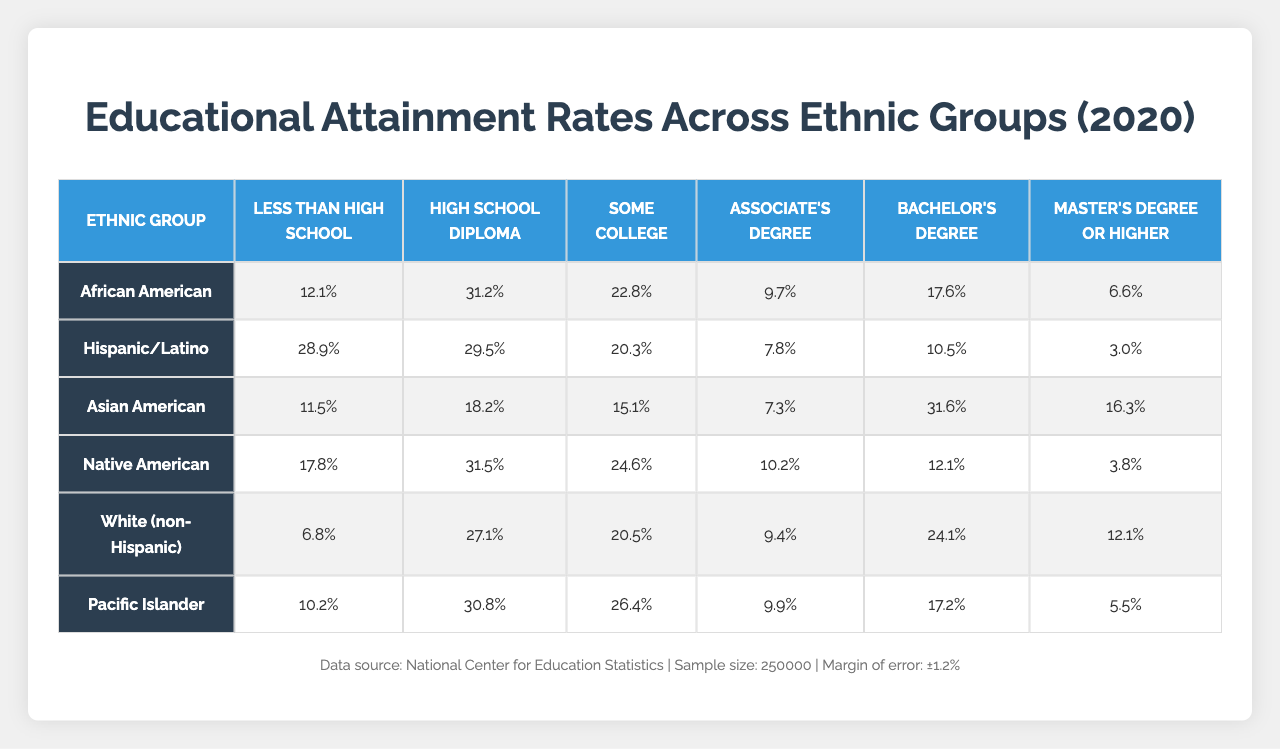What is the education attainment rate for Asian Americans for a Bachelor's Degree? The table lists the attainment rates for each ethnic group across various education levels. For Asian Americans, the rate for a Bachelor's Degree is shown in the corresponding cell.
Answer: 31.6% Which ethnic group has the highest rate of individuals with less than a High School education? By examining the first column of the table, we identify the attainment rates for "Less than High School" across all listed ethnic groups. The highest rate is associated with the Hispanic/Latino group.
Answer: Hispanic/Latino What is the combined percentage of Native Americans with a Bachelor's Degree and a Master’s Degree or Higher? The rates for Native Americans are found in the Bachelor's Degree (12.1%) and Master's Degree or Higher (3.8%) rows. Adding these rates gives us the combined percentage: 12.1 + 3.8 = 15.9.
Answer: 15.9% Do more than 30% of Pacific Islanders have a High School Diploma? The rate for Pacific Islanders with a High School Diploma is in the relevant cell, which shows 30.8%. Since 30.8% is not more than 30%, the answer is no.
Answer: No What is the difference in the percentage of African Americans and Hispanics with an Associate's Degree? The table provides the percentages for African Americans (9.7%) and Hispanics (7.8%) under the Associate's Degree row. The difference calculated by subtracting 7.8 from 9.7 is 1.9.
Answer: 1.9% Which ethnic group has the lowest percentage of individuals with a Master's Degree or Higher? By examining the last column for each ethnic group, we see that the Pacific Islander group has the lowest value at 5.5%.
Answer: Pacific Islander What is the average education attainment rate for 'Some College' across all ethnic groups? To find the average, we add the 'Some College' rates (22.8, 20.3, 15.1, 24.6, 20.5, 26.4) and divide by the number of groups (6): (22.8 + 20.3 + 15.1 + 24.6 + 20.5 + 26.4) / 6 = 19.9.
Answer: 19.9% Is it true that the percentage of White (non-Hispanic) individuals with a High School Diploma is higher than that of Native Americans? The rates for the High School Diploma are 27.1% for White (non-Hispanic) and 31.5% for Native Americans. Since 27.1% is not higher than 31.5%, the statement is false.
Answer: No Which educational attainment level shows the widest disparity between the highest and lowest rate among all groups? By comparing the rates across all levels, we find 'Less than High School' has 28.9% (Hispanic/Latino) and 6.8% (White), which is a 22.1% difference. Thus, this category exhibits the widest disparity.
Answer: Less than High School 